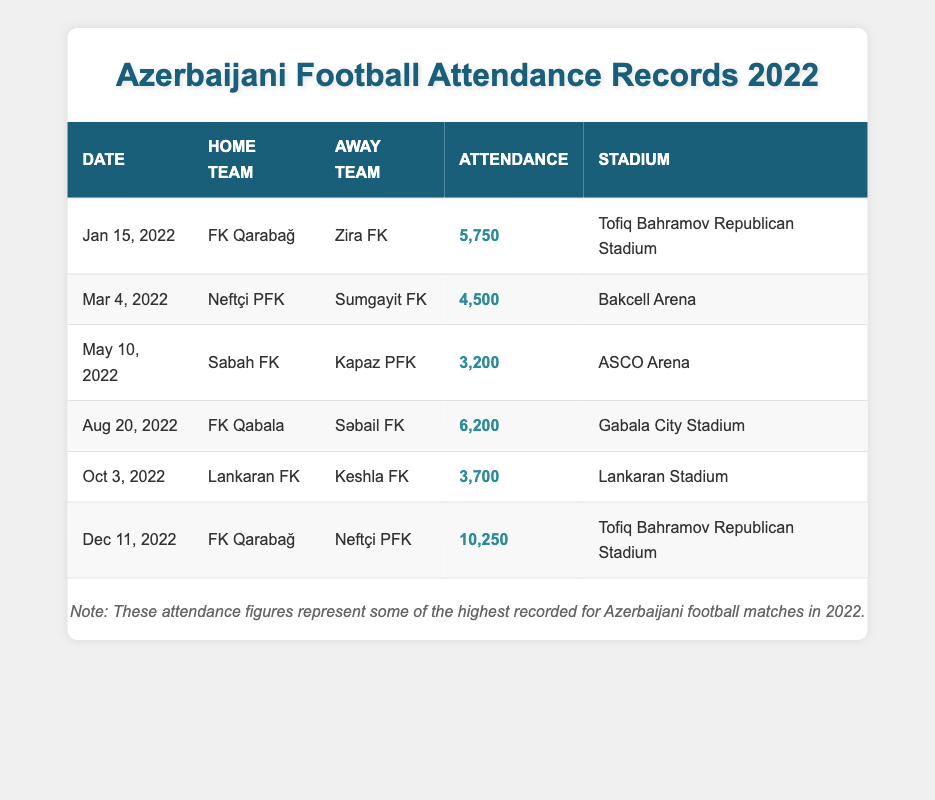What was the attendance for the match between FK Qarabağ and Zira FK? The attendance for the match on January 15, 2022, where FK Qarabağ faced Zira FK, is listed in the table as 5750.
Answer: 5750 Which match had the highest attendance in 2022? By examining the attendance figures for all matches, the highest attendance is found in the match on December 11, 2022, between FK Qarabağ and Neftçi PFK, with an attendance of 10250.
Answer: 10250 How many matches had an attendance of over 5000? Looking through the attendance records, there are 3 matches where the attendance exceeds 5000: the matches on January 15 (5750), August 20 (6200), and December 11 (10250).
Answer: 3 What was the average attendance across all matches? To find the average, we add up the attendances: 5750 + 4500 + 3200 + 6200 + 3700 + 10250 =  26300. There are 6 matches total, so the average is 26300 / 6 = 4383.33, rounded to 4383.
Answer: 4383 Did any match take place at Lankaran Stadium? Yes, there was a match between Lankaran FK and Keshla FK that took place on October 3, 2022, at Lankaran Stadium as indicated in the table.
Answer: Yes Which two teams played at the Tofiq Bahramov Republican Stadium in 2022? The matches at Tofiq Bahramov Republican Stadium involved FK Qarabağ playing against Zira FK on January 15 and against Neftçi PFK on December 11, 2022.
Answer: FK Qarabağ and Neftçi PFK What is the difference in attendance between the match on August 20 and the match on October 3? The attendance for the August 20 match is 6200 (FK Qabala vs. Səbail FK) and for the October 3 match it is 3700 (Lankaran FK vs. Keshla FK). The difference is 6200 - 3700 = 2500.
Answer: 2500 How many goals might the teams have needed to score to attract large crowds? This question requires speculation since attendance does not correlate directly with goals scored, but generally, high-scoring matches tend to attract larger crowds. For instance, the highest attendance was during a match that likely featured exciting gameplay, but exact goal numbers aren't provided in the table.
Answer: Not applicable 